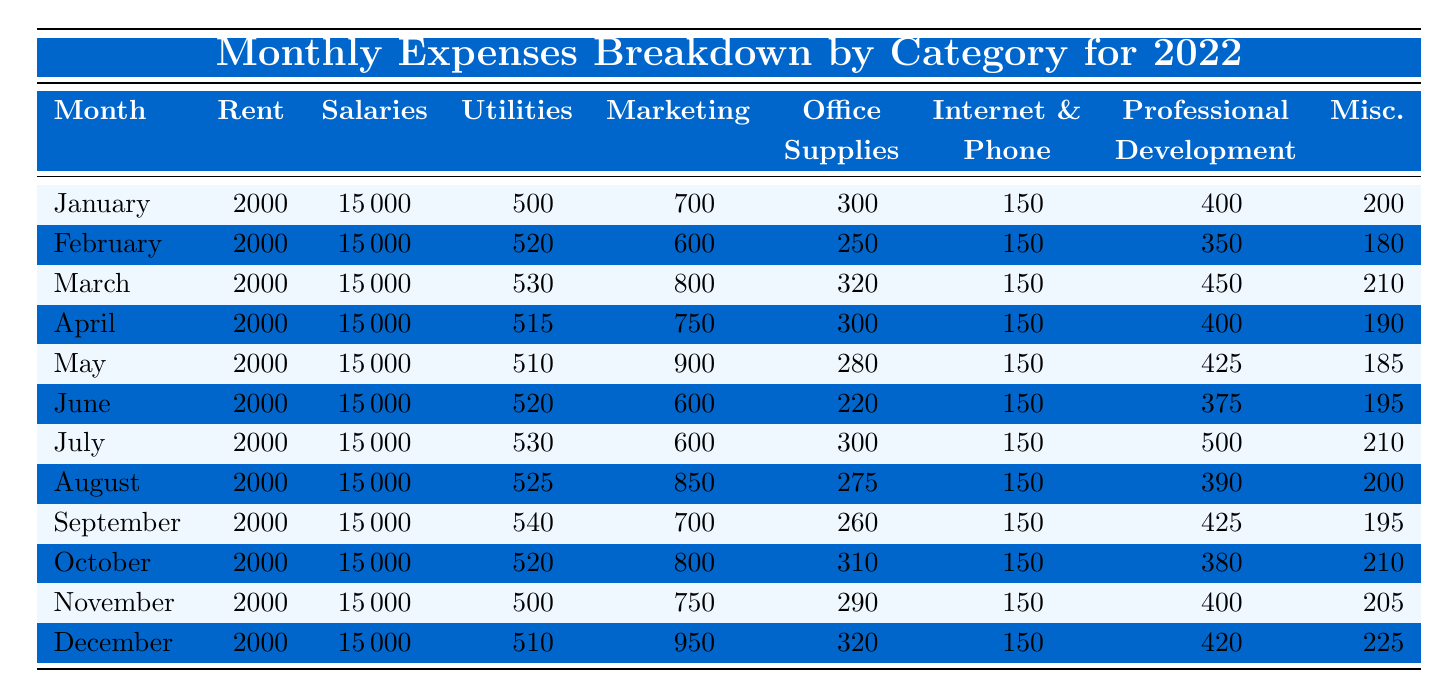What is the total amount spent on salaries in January? The table shows that the salary expense for January is 15000. Since this is a direct retrieval from the table, the total amount spent on salaries in January is simply the value presented for that month.
Answer: 15000 What was the highest marketing expense in a month during 2022? Looking through the marketing expenses for each month, the highest amount appeared in December, where the expense was 950. This can be confirmed by scanning through the marketing column for each month.
Answer: 950 What is the average utility expense for the year 2022? To find the average utility expense, I first add all the utility costs from each month: (500 + 520 + 530 + 515 + 510 + 520 + 530 + 525 + 540 + 520 + 500 + 510) = 6190. Then, I divide this sum by the number of months, which is 12. Therefore, the average is 6190 / 12 = 515.83.
Answer: 515.83 Was the total rent expense higher than 24000 in 2022? The rent expense is constant at 2000 each month. For 12 months, this totals to 2000 * 12 = 24000. Therefore, the rent expense is equal to 24000, not higher. Thus, the answer is false.
Answer: No Which month had the lowest total miscellaneous expenses? To determine this, I review the miscellaneous expenses for each month: January (200), February (180), March (210), April (190), May (185), June (195), July (210), August (200), September (195), October (210), November (205), December (225). The minimum is in February with 180.
Answer: February What was the total office supplies expense across all months? The office supplies expenses by month are: January (300), February (250), March (320), April (300), May (280), June (220), July (300), August (275), September (260), October (310), November (290), December (320). I sum these values: 300 + 250 + 320 + 300 + 280 + 220 + 300 + 275 + 260 + 310 + 290 + 320 = 3,197.
Answer: 3197 In which month was the professional development expense equal to 400? I scan through the professional development expenses in the table and find that January and April show this exact expense of 400. Therefore, the answer includes these two months.
Answer: January, April What is the difference in salaries between the month with the highest marketing expense and the month with the lowest? The highest marketing expense was in December (950) and the lowest was in February (600). Both months had consistent salaries of 15000, so the difference in salaries remains 15000 - 15000 = 0.
Answer: 0 